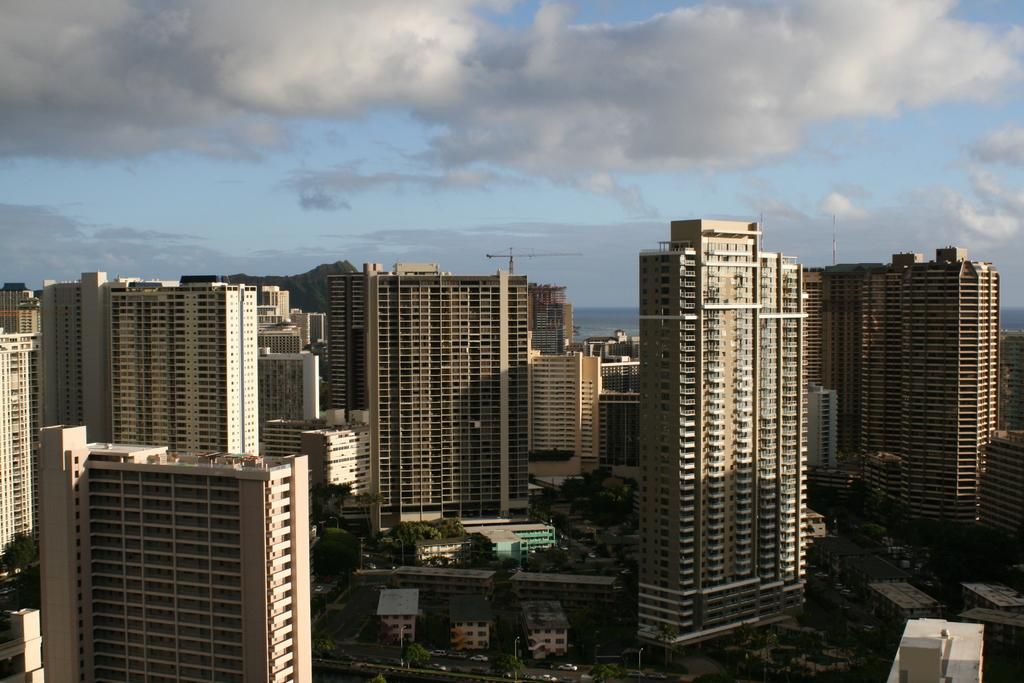What type of structures can be seen in the image? There are buildings in the image. What other natural elements are present in the image? There are trees in the image. What mode of transportation can be seen on the road in the image? There are vehicles on the road in the image. How would you describe the weather based on the image? The sky is cloudy in the image. What type of liquid is being poured during the protest scene in the image? There is no protest scene or liquid being poured in the image; it features buildings, trees, vehicles, and a cloudy sky. 